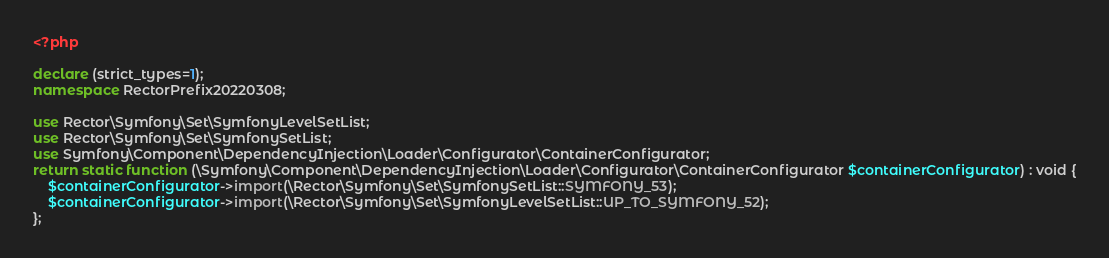Convert code to text. <code><loc_0><loc_0><loc_500><loc_500><_PHP_><?php

declare (strict_types=1);
namespace RectorPrefix20220308;

use Rector\Symfony\Set\SymfonyLevelSetList;
use Rector\Symfony\Set\SymfonySetList;
use Symfony\Component\DependencyInjection\Loader\Configurator\ContainerConfigurator;
return static function (\Symfony\Component\DependencyInjection\Loader\Configurator\ContainerConfigurator $containerConfigurator) : void {
    $containerConfigurator->import(\Rector\Symfony\Set\SymfonySetList::SYMFONY_53);
    $containerConfigurator->import(\Rector\Symfony\Set\SymfonyLevelSetList::UP_TO_SYMFONY_52);
};
</code> 